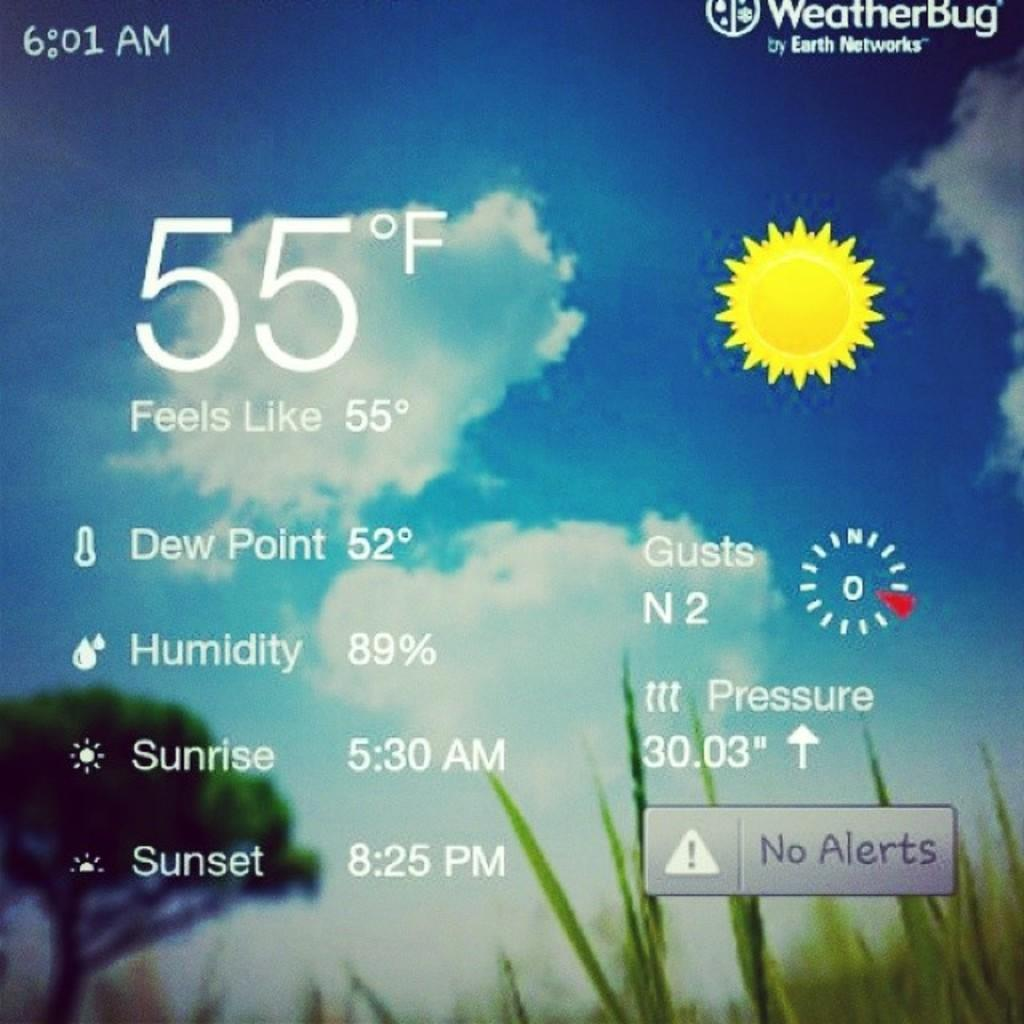What is the color of the sky in the image? The sky in the image is blue and slightly cloudy. What celestial object is present in the image? There is an animated sun in the image. Are there any words or phrases in the image? Yes, there is some text in the image. What type of vegetation can be seen in the image? There is a tree and grass in the image. What type of dress is the teacher wearing in the image? There is no teacher or dress present in the image. How much payment is being made in the image? There is no payment being made in the image. 